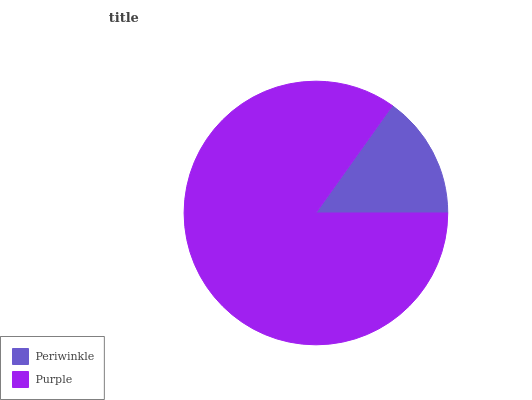Is Periwinkle the minimum?
Answer yes or no. Yes. Is Purple the maximum?
Answer yes or no. Yes. Is Purple the minimum?
Answer yes or no. No. Is Purple greater than Periwinkle?
Answer yes or no. Yes. Is Periwinkle less than Purple?
Answer yes or no. Yes. Is Periwinkle greater than Purple?
Answer yes or no. No. Is Purple less than Periwinkle?
Answer yes or no. No. Is Purple the high median?
Answer yes or no. Yes. Is Periwinkle the low median?
Answer yes or no. Yes. Is Periwinkle the high median?
Answer yes or no. No. Is Purple the low median?
Answer yes or no. No. 